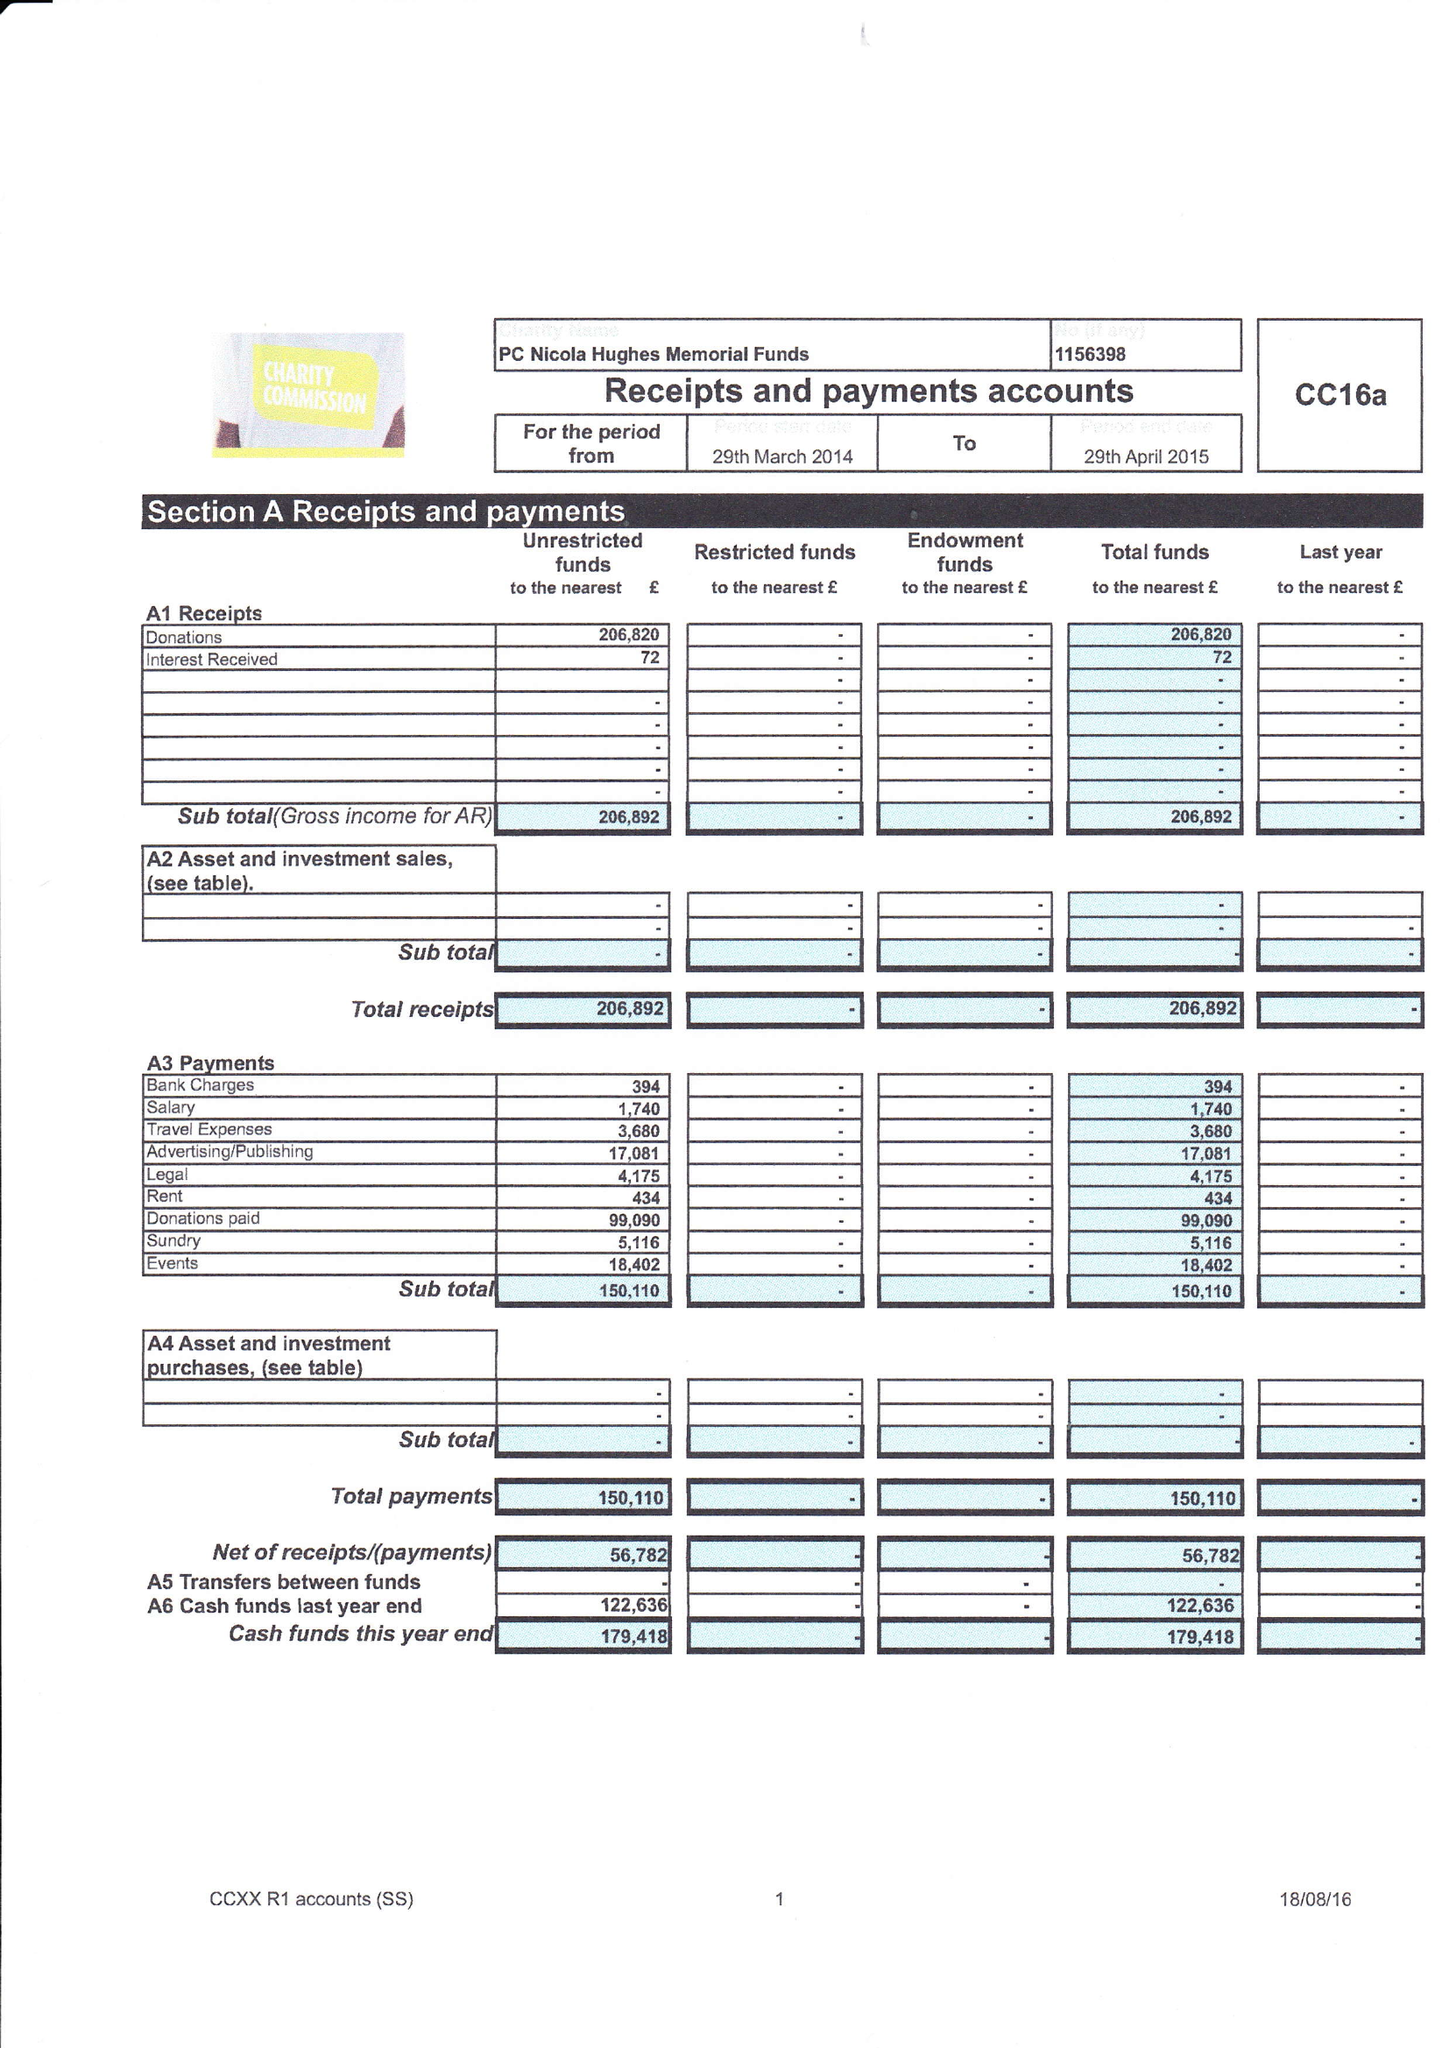What is the value for the charity_number?
Answer the question using a single word or phrase. 1156398 